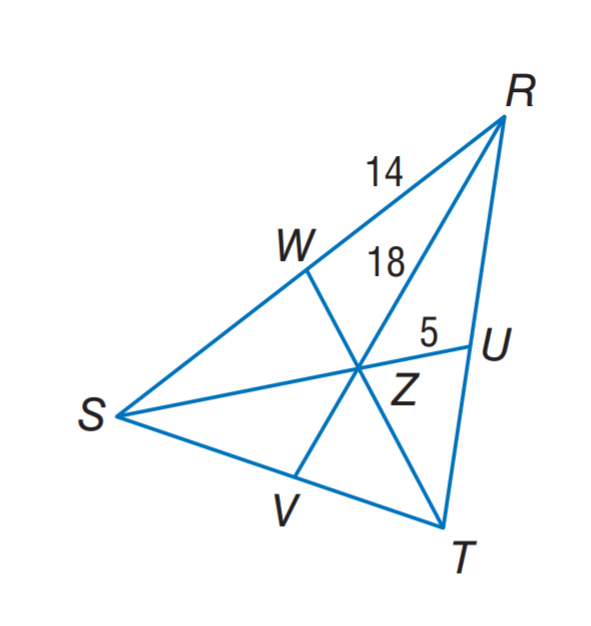Answer the mathemtical geometry problem and directly provide the correct option letter.
Question: In \triangle R S T, Z is the centroid and R Z = 18. Find S R.
Choices: A: 10 B: 14 C: 18 D: 28 D 